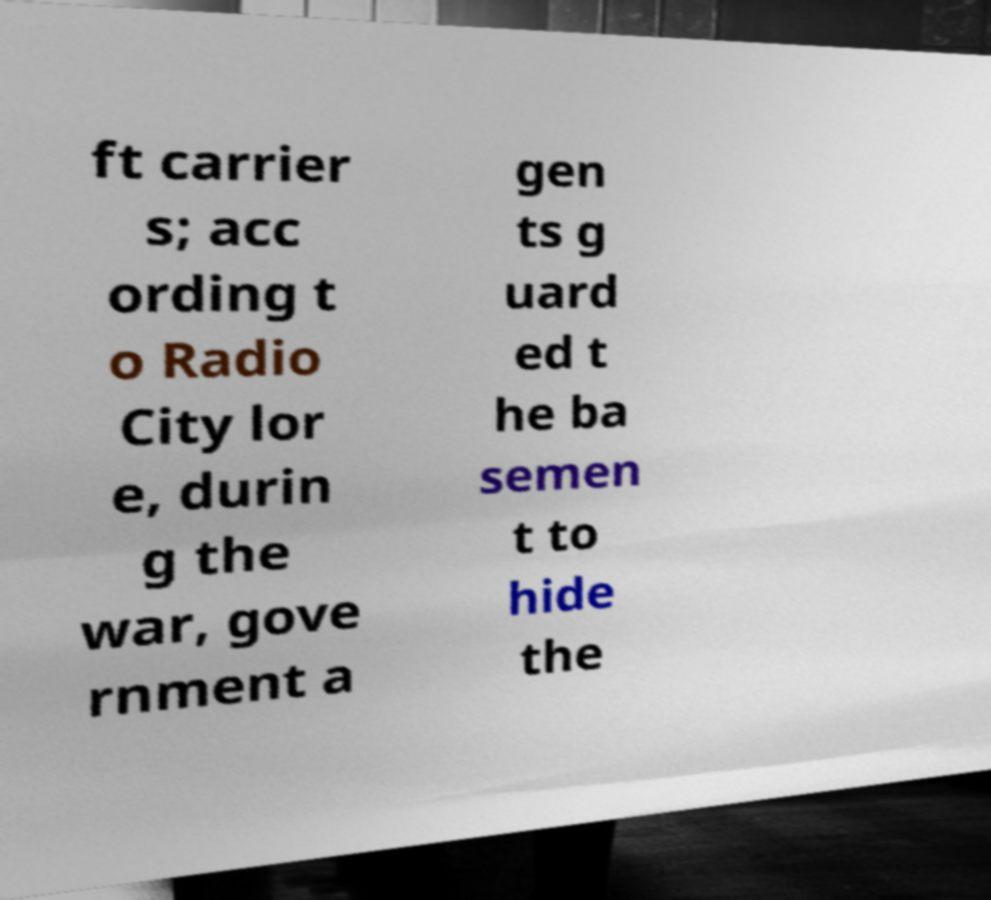Can you accurately transcribe the text from the provided image for me? ft carrier s; acc ording t o Radio City lor e, durin g the war, gove rnment a gen ts g uard ed t he ba semen t to hide the 